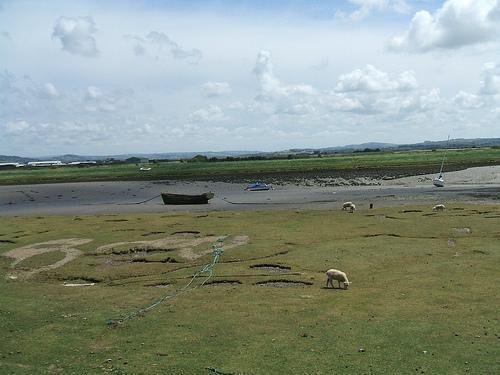How many sheet are in picture?
Give a very brief answer. 3. 